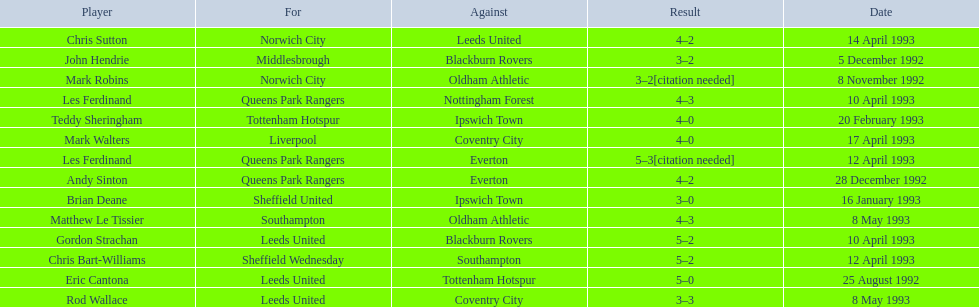What are the results? 5–0, 3–2[citation needed], 3–2, 4–2, 3–0, 4–0, 5–2, 4–3, 5–2, 5–3[citation needed], 4–2, 4–0, 3–3, 4–3. What result did mark robins have? 3–2[citation needed]. What other player had that result? John Hendrie. 